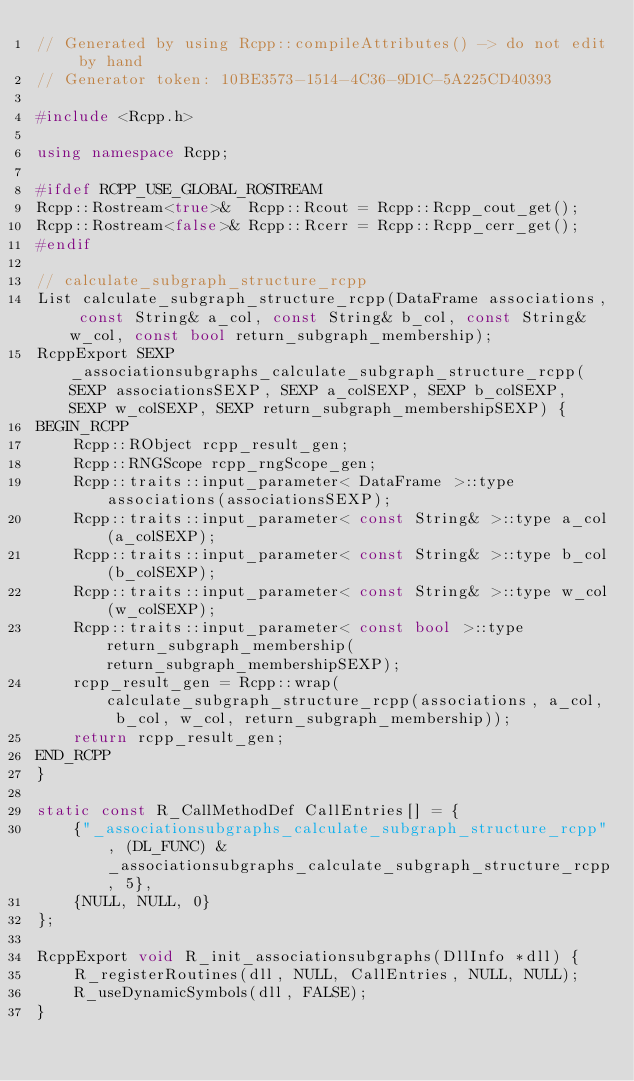Convert code to text. <code><loc_0><loc_0><loc_500><loc_500><_C++_>// Generated by using Rcpp::compileAttributes() -> do not edit by hand
// Generator token: 10BE3573-1514-4C36-9D1C-5A225CD40393

#include <Rcpp.h>

using namespace Rcpp;

#ifdef RCPP_USE_GLOBAL_ROSTREAM
Rcpp::Rostream<true>&  Rcpp::Rcout = Rcpp::Rcpp_cout_get();
Rcpp::Rostream<false>& Rcpp::Rcerr = Rcpp::Rcpp_cerr_get();
#endif

// calculate_subgraph_structure_rcpp
List calculate_subgraph_structure_rcpp(DataFrame associations, const String& a_col, const String& b_col, const String& w_col, const bool return_subgraph_membership);
RcppExport SEXP _associationsubgraphs_calculate_subgraph_structure_rcpp(SEXP associationsSEXP, SEXP a_colSEXP, SEXP b_colSEXP, SEXP w_colSEXP, SEXP return_subgraph_membershipSEXP) {
BEGIN_RCPP
    Rcpp::RObject rcpp_result_gen;
    Rcpp::RNGScope rcpp_rngScope_gen;
    Rcpp::traits::input_parameter< DataFrame >::type associations(associationsSEXP);
    Rcpp::traits::input_parameter< const String& >::type a_col(a_colSEXP);
    Rcpp::traits::input_parameter< const String& >::type b_col(b_colSEXP);
    Rcpp::traits::input_parameter< const String& >::type w_col(w_colSEXP);
    Rcpp::traits::input_parameter< const bool >::type return_subgraph_membership(return_subgraph_membershipSEXP);
    rcpp_result_gen = Rcpp::wrap(calculate_subgraph_structure_rcpp(associations, a_col, b_col, w_col, return_subgraph_membership));
    return rcpp_result_gen;
END_RCPP
}

static const R_CallMethodDef CallEntries[] = {
    {"_associationsubgraphs_calculate_subgraph_structure_rcpp", (DL_FUNC) &_associationsubgraphs_calculate_subgraph_structure_rcpp, 5},
    {NULL, NULL, 0}
};

RcppExport void R_init_associationsubgraphs(DllInfo *dll) {
    R_registerRoutines(dll, NULL, CallEntries, NULL, NULL);
    R_useDynamicSymbols(dll, FALSE);
}
</code> 